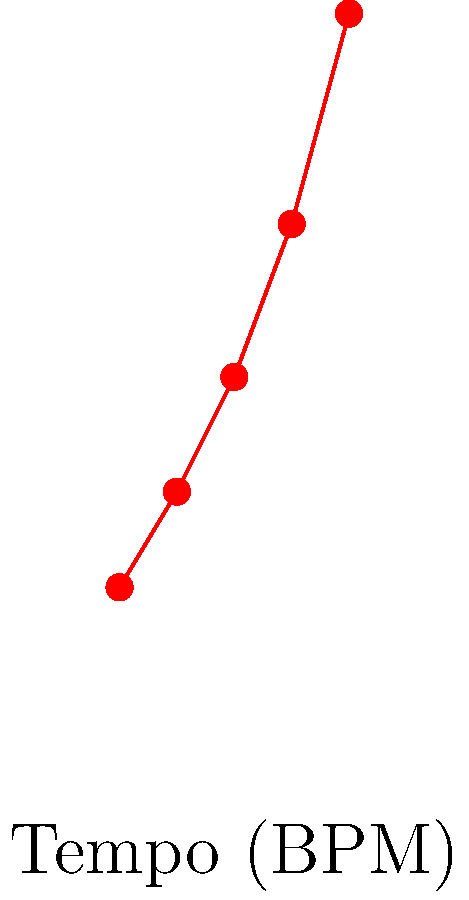Based on the graph showing the relationship between drumming tempo and energy expenditure, what is the approximate rate of change in energy expenditure (in kcal/hr per BPM) between 120 BPM and 180 BPM? To calculate the rate of change in energy expenditure between 120 BPM and 180 BPM:

1. Identify the energy expenditure values:
   At 120 BPM: approximately 210 kcal/hr
   At 180 BPM: approximately 400 kcal/hr

2. Calculate the change in energy expenditure:
   $\Delta E = 400 - 210 = 190$ kcal/hr

3. Calculate the change in tempo:
   $\Delta T = 180 - 120 = 60$ BPM

4. Calculate the rate of change:
   Rate = $\frac{\Delta E}{\Delta T} = \frac{190 \text{ kcal/hr}}{60 \text{ BPM}} = \frac{19}{6} \approx 3.17$ kcal/hr per BPM

Therefore, the approximate rate of change in energy expenditure between 120 BPM and 180 BPM is 3.17 kcal/hr per BPM.
Answer: 3.17 kcal/hr per BPM 